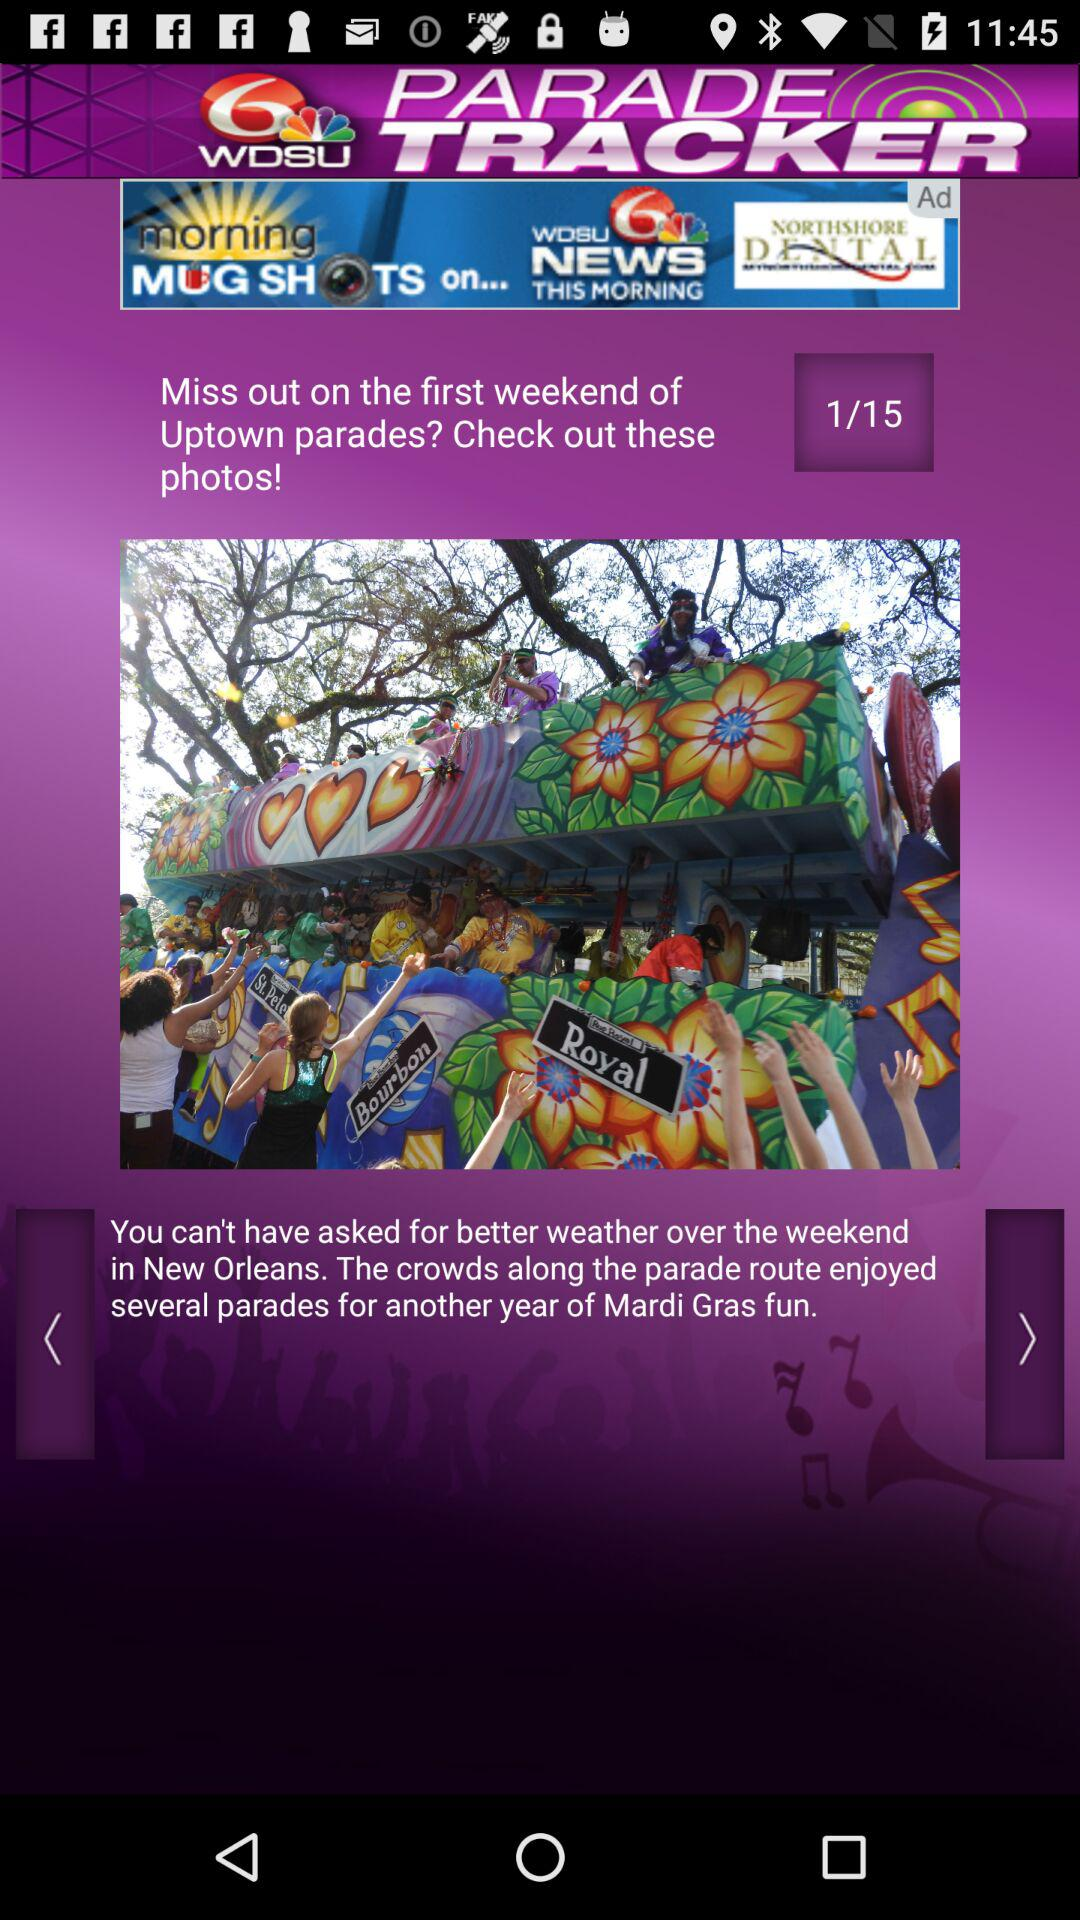What's the total count of photos? The total count of photos is 15. 